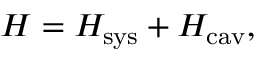<formula> <loc_0><loc_0><loc_500><loc_500>{ H } = H _ { s y s } + H _ { c a v } ,</formula> 